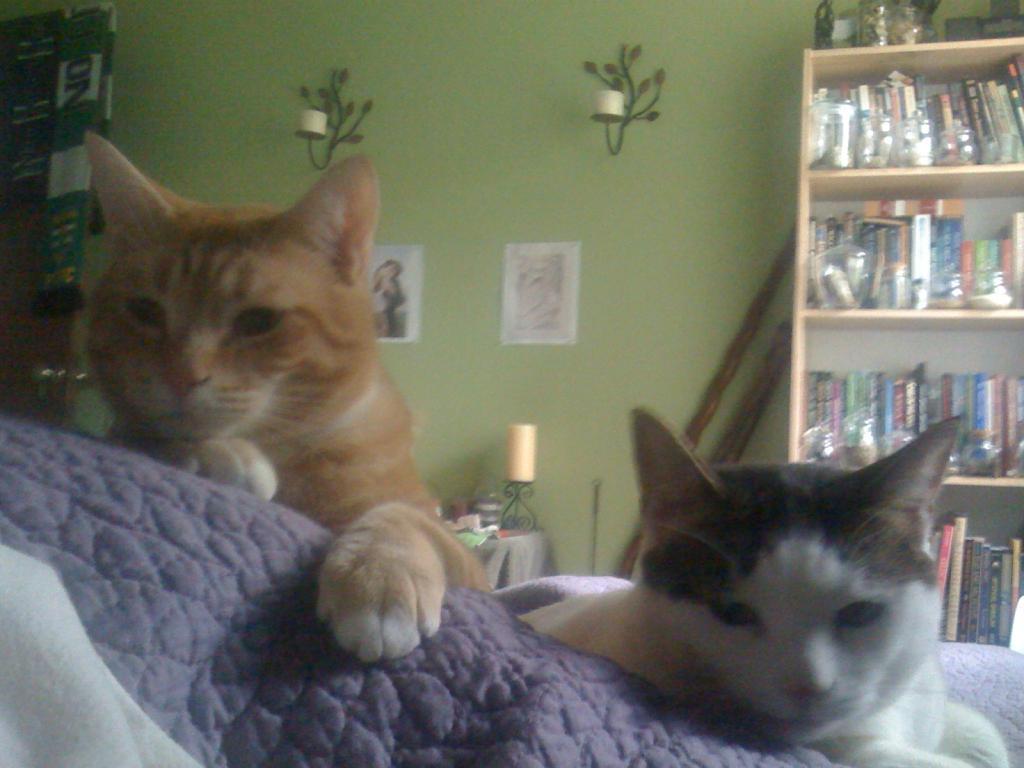In one or two sentences, can you explain what this image depicts? As we can see in the image there is a wall, rack filled with books, cats, papers, lamp and a table. 